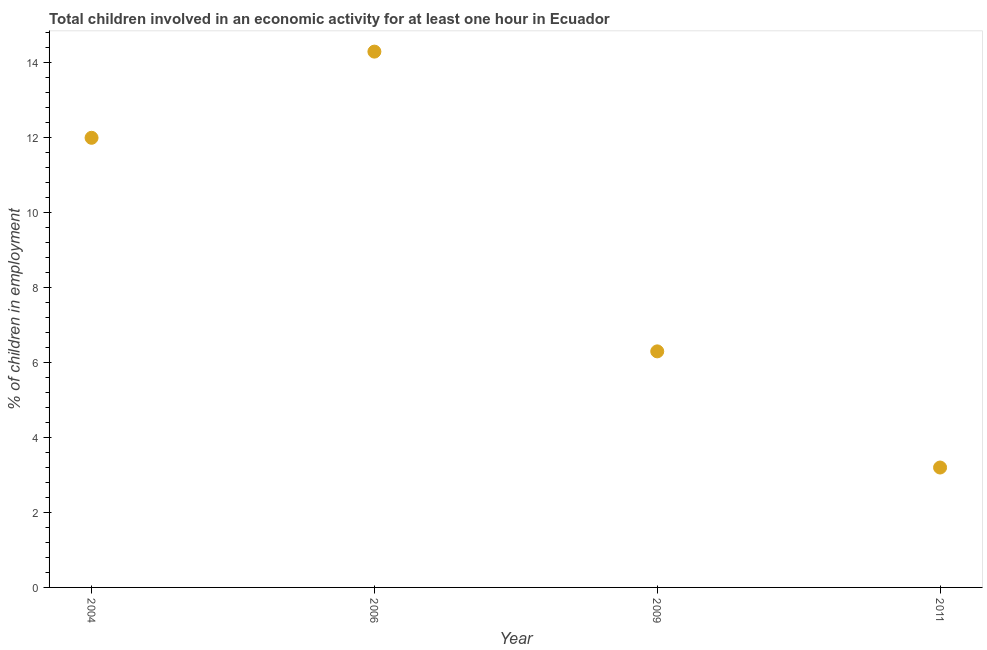In which year was the percentage of children in employment minimum?
Your response must be concise. 2011. What is the sum of the percentage of children in employment?
Offer a very short reply. 35.8. What is the difference between the percentage of children in employment in 2009 and 2011?
Offer a terse response. 3.1. What is the average percentage of children in employment per year?
Offer a terse response. 8.95. What is the median percentage of children in employment?
Ensure brevity in your answer.  9.15. What is the ratio of the percentage of children in employment in 2006 to that in 2009?
Your answer should be compact. 2.27. What is the difference between the highest and the second highest percentage of children in employment?
Offer a very short reply. 2.3. What is the difference between the highest and the lowest percentage of children in employment?
Offer a very short reply. 11.1. Does the percentage of children in employment monotonically increase over the years?
Keep it short and to the point. No. How many dotlines are there?
Provide a succinct answer. 1. What is the difference between two consecutive major ticks on the Y-axis?
Give a very brief answer. 2. Does the graph contain grids?
Offer a terse response. No. What is the title of the graph?
Your answer should be very brief. Total children involved in an economic activity for at least one hour in Ecuador. What is the label or title of the Y-axis?
Offer a very short reply. % of children in employment. What is the % of children in employment in 2004?
Give a very brief answer. 12. What is the % of children in employment in 2006?
Ensure brevity in your answer.  14.3. What is the % of children in employment in 2011?
Provide a succinct answer. 3.2. What is the difference between the % of children in employment in 2006 and 2011?
Give a very brief answer. 11.1. What is the difference between the % of children in employment in 2009 and 2011?
Keep it short and to the point. 3.1. What is the ratio of the % of children in employment in 2004 to that in 2006?
Your answer should be very brief. 0.84. What is the ratio of the % of children in employment in 2004 to that in 2009?
Offer a terse response. 1.91. What is the ratio of the % of children in employment in 2004 to that in 2011?
Give a very brief answer. 3.75. What is the ratio of the % of children in employment in 2006 to that in 2009?
Your answer should be compact. 2.27. What is the ratio of the % of children in employment in 2006 to that in 2011?
Ensure brevity in your answer.  4.47. What is the ratio of the % of children in employment in 2009 to that in 2011?
Ensure brevity in your answer.  1.97. 